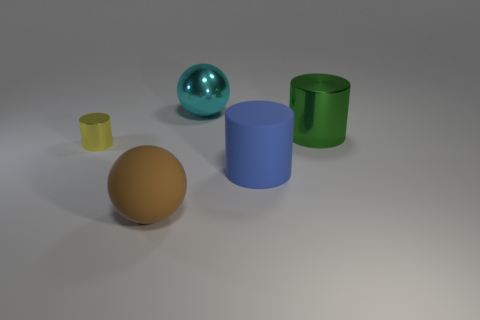Are there any other things that have the same size as the yellow metallic object?
Provide a succinct answer. No. Is the number of blue objects on the left side of the green shiny thing less than the number of cyan things?
Your answer should be very brief. No. There is a green cylinder that is the same size as the cyan sphere; what is its material?
Make the answer very short. Metal. What number of tiny objects are either yellow matte things or cyan metal spheres?
Provide a short and direct response. 0. What number of objects are things right of the tiny yellow shiny object or spheres that are in front of the cyan metallic ball?
Offer a terse response. 4. Are there fewer big shiny cylinders than small gray matte cylinders?
Provide a short and direct response. No. There is a green metal thing that is the same size as the brown matte sphere; what shape is it?
Your answer should be very brief. Cylinder. What number of other things are the same color as the tiny thing?
Ensure brevity in your answer.  0. What number of large brown shiny objects are there?
Offer a terse response. 0. How many objects are both behind the small cylinder and on the right side of the cyan object?
Provide a succinct answer. 1. 